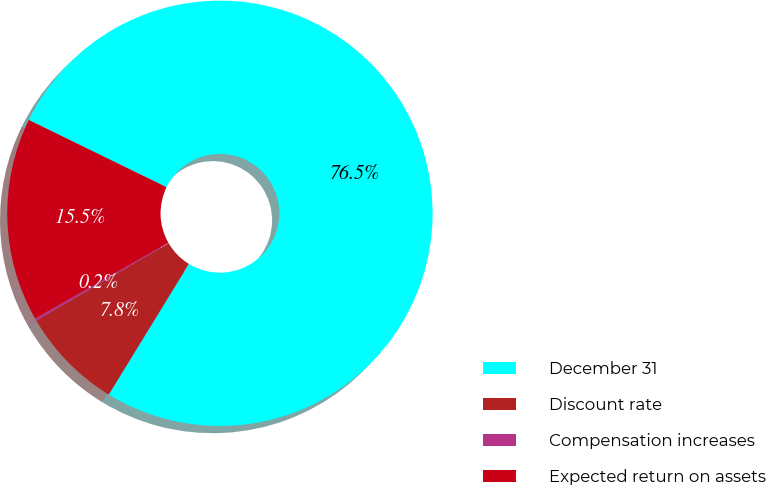Convert chart. <chart><loc_0><loc_0><loc_500><loc_500><pie_chart><fcel>December 31<fcel>Discount rate<fcel>Compensation increases<fcel>Expected return on assets<nl><fcel>76.53%<fcel>7.82%<fcel>0.19%<fcel>15.46%<nl></chart> 